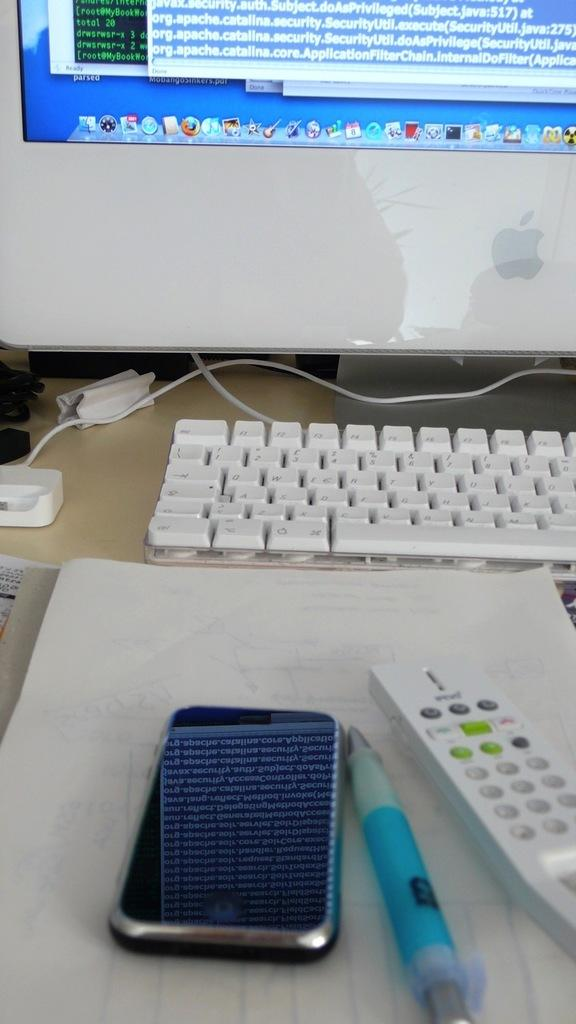Provide a one-sentence caption for the provided image. A CELL PHONE, PEN ANF REMOTE ON TABLE IN FRONT OF A MAC COMPUTER AND KEYBOARD. 